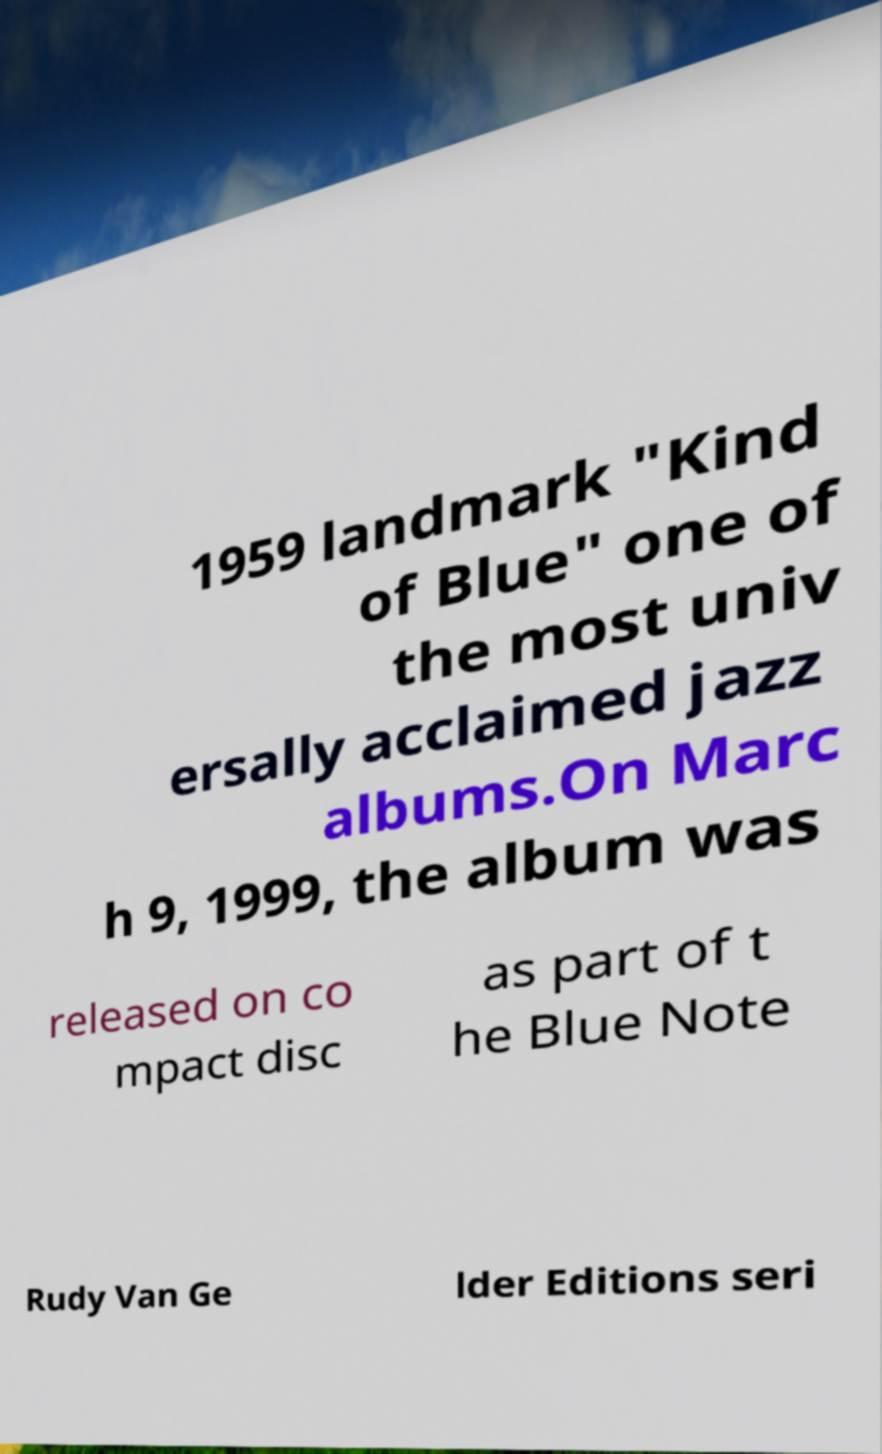Could you extract and type out the text from this image? 1959 landmark "Kind of Blue" one of the most univ ersally acclaimed jazz albums.On Marc h 9, 1999, the album was released on co mpact disc as part of t he Blue Note Rudy Van Ge lder Editions seri 